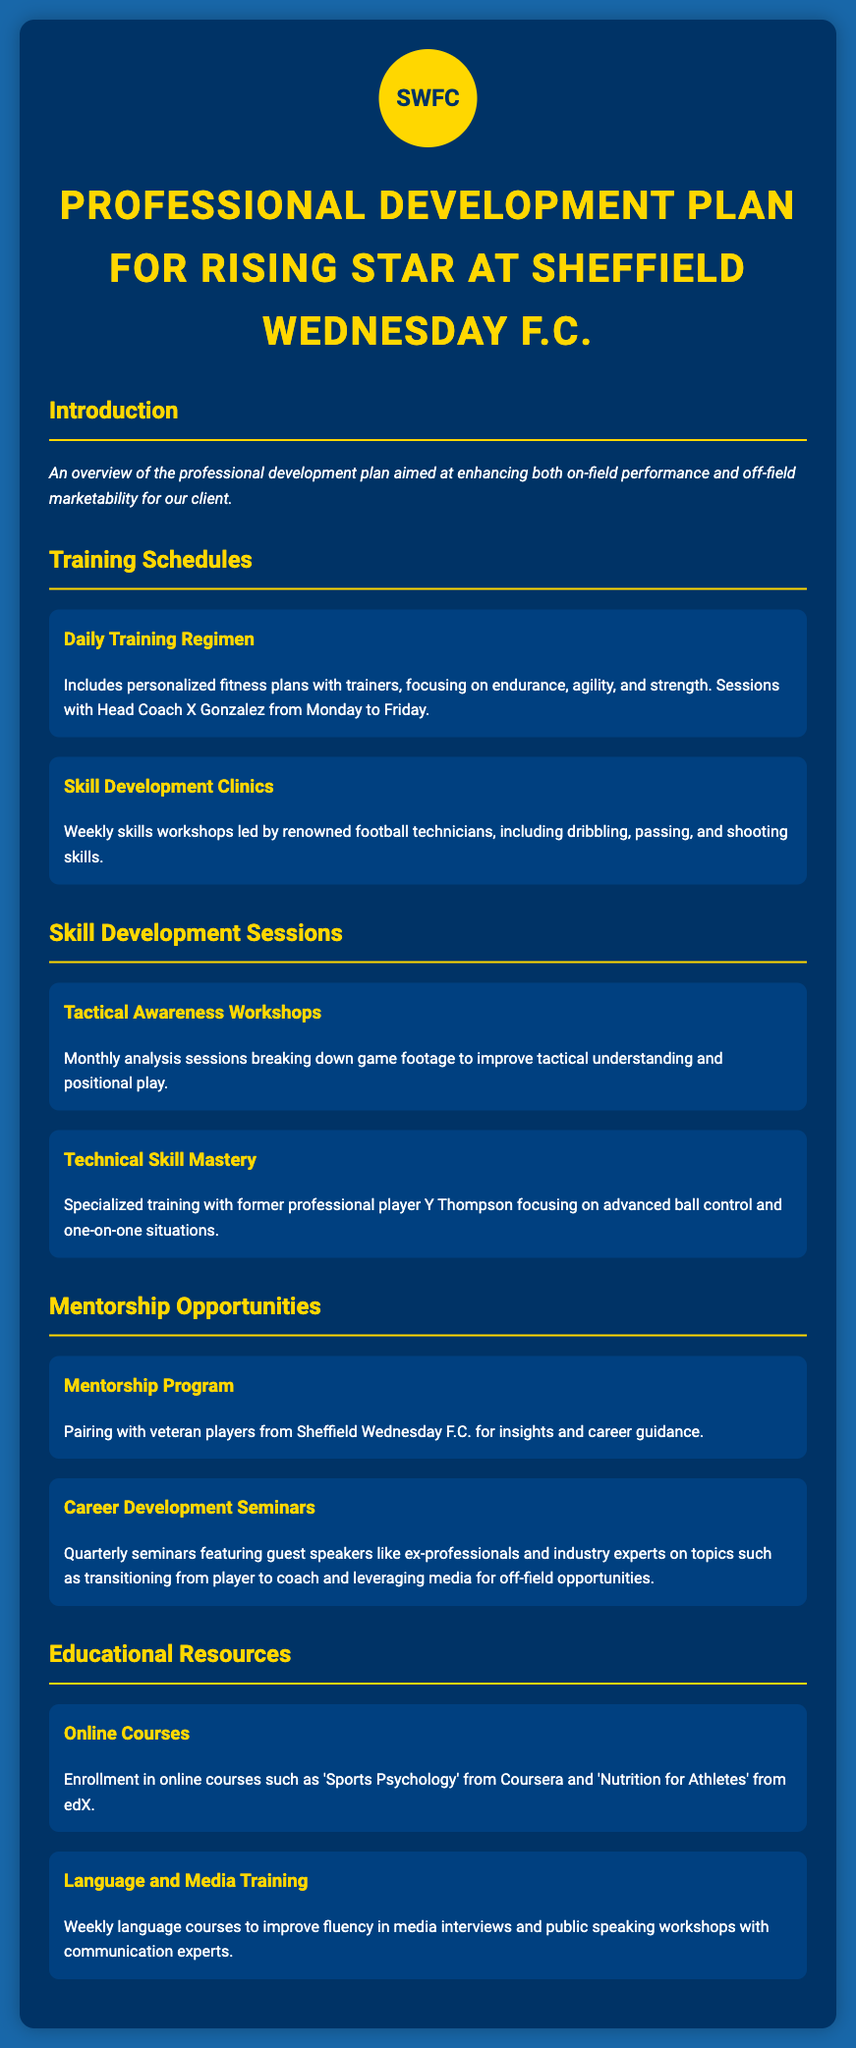what is the title of the document? The title of the document is found at the top of the rendered content, which indicates the purpose and focus of the plan.
Answer: Professional Development Plan for Rising Star at Sheffield Wednesday F.C who leads the skill development clinics? This question is about identifying the person responsible for the workshops designed for improving skills in the sport based on the document.
Answer: Renowned football technicians how often are tactical awareness workshops held? The document states the frequency of these workshops, providing clear information on their scheduling.
Answer: Monthly what types of seminars are included in the mentorship opportunities? This involves understanding the nature of the seminars mentioned in the plan regarding career development based on the details provided.
Answer: Career Development Seminars what online course is offered related to nutrition? The document references a specific online course focusing on nutrition that is part of the educational resources section.
Answer: Nutrition for Athletes how frequently do the daily training sessions occur? The answer to this question pertains to understanding the schedule of the training regimen to know its consistency.
Answer: Monday to Friday what is the primary focus of the mentorship program? This question revolves around the key purpose of pairing with veteran players as outlined in the document.
Answer: Insights and career guidance who conducts the specialized training for technical skill mastery? This involves determining the individual that leads specialized training sessions as detailed in the document.
Answer: Former professional player Y Thompson 